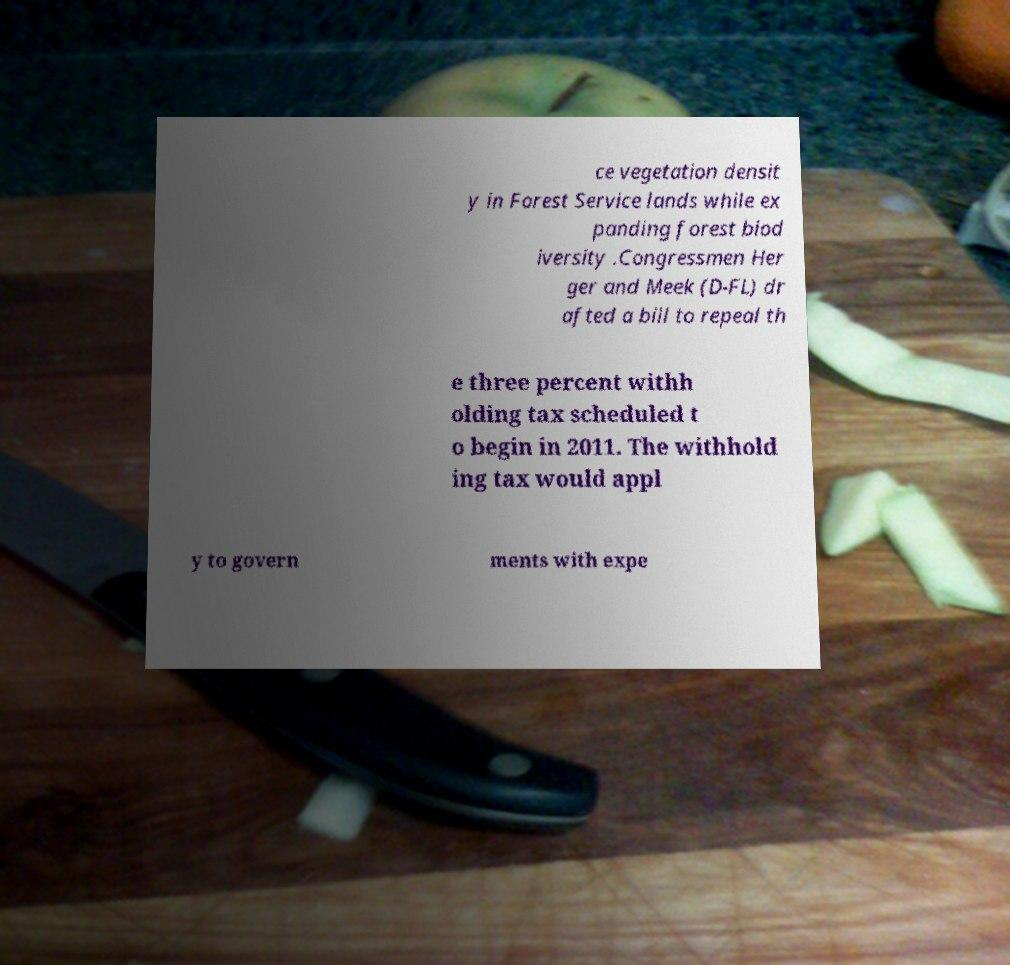Could you extract and type out the text from this image? ce vegetation densit y in Forest Service lands while ex panding forest biod iversity .Congressmen Her ger and Meek (D-FL) dr afted a bill to repeal th e three percent withh olding tax scheduled t o begin in 2011. The withhold ing tax would appl y to govern ments with expe 